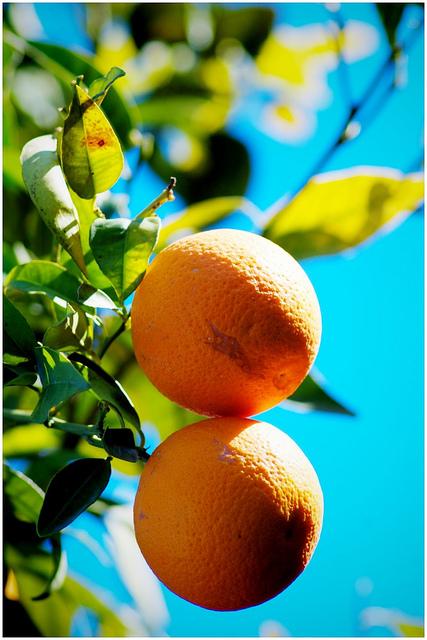Is the sky blue?
Answer briefly. Yes. How many oranges?
Keep it brief. 2. Are the oranges ready to pick?
Be succinct. Yes. 